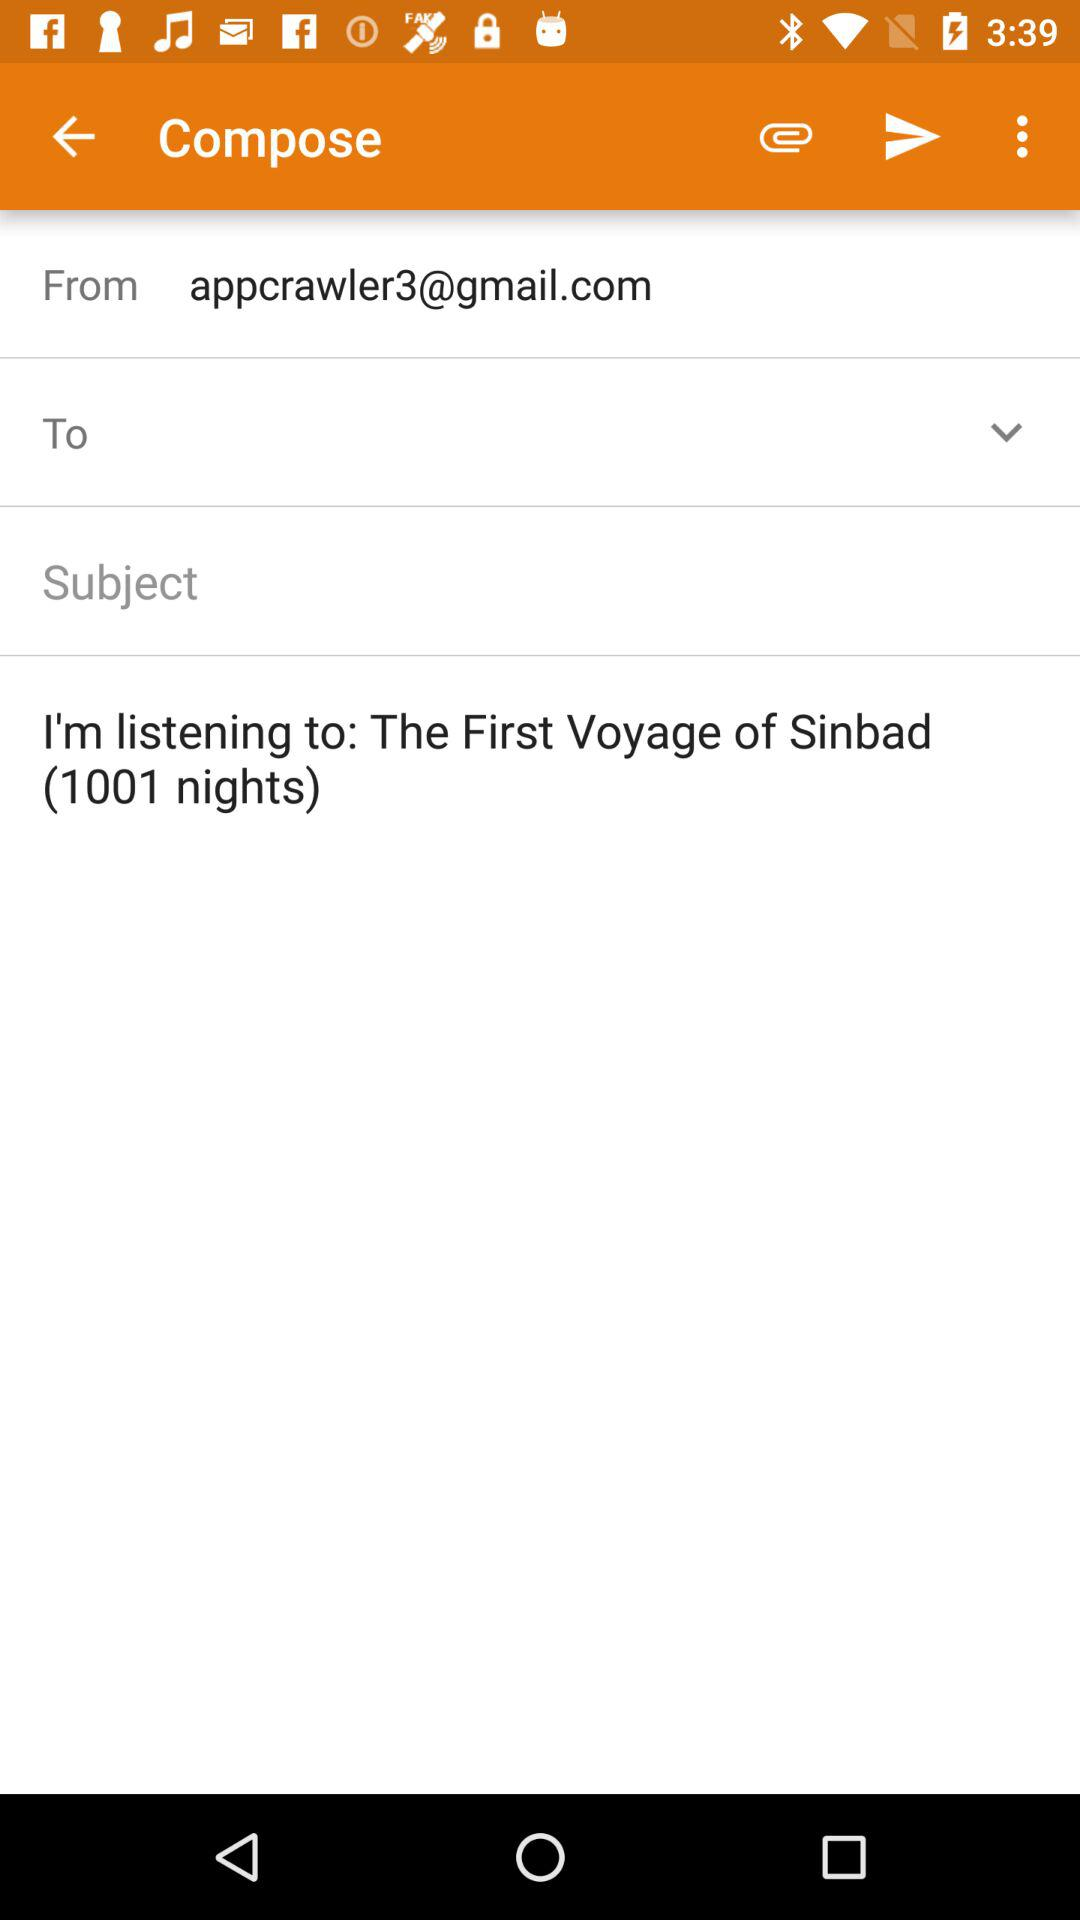What is the displayed email address? The displayed email address is appcrawler3@gmail.com. 